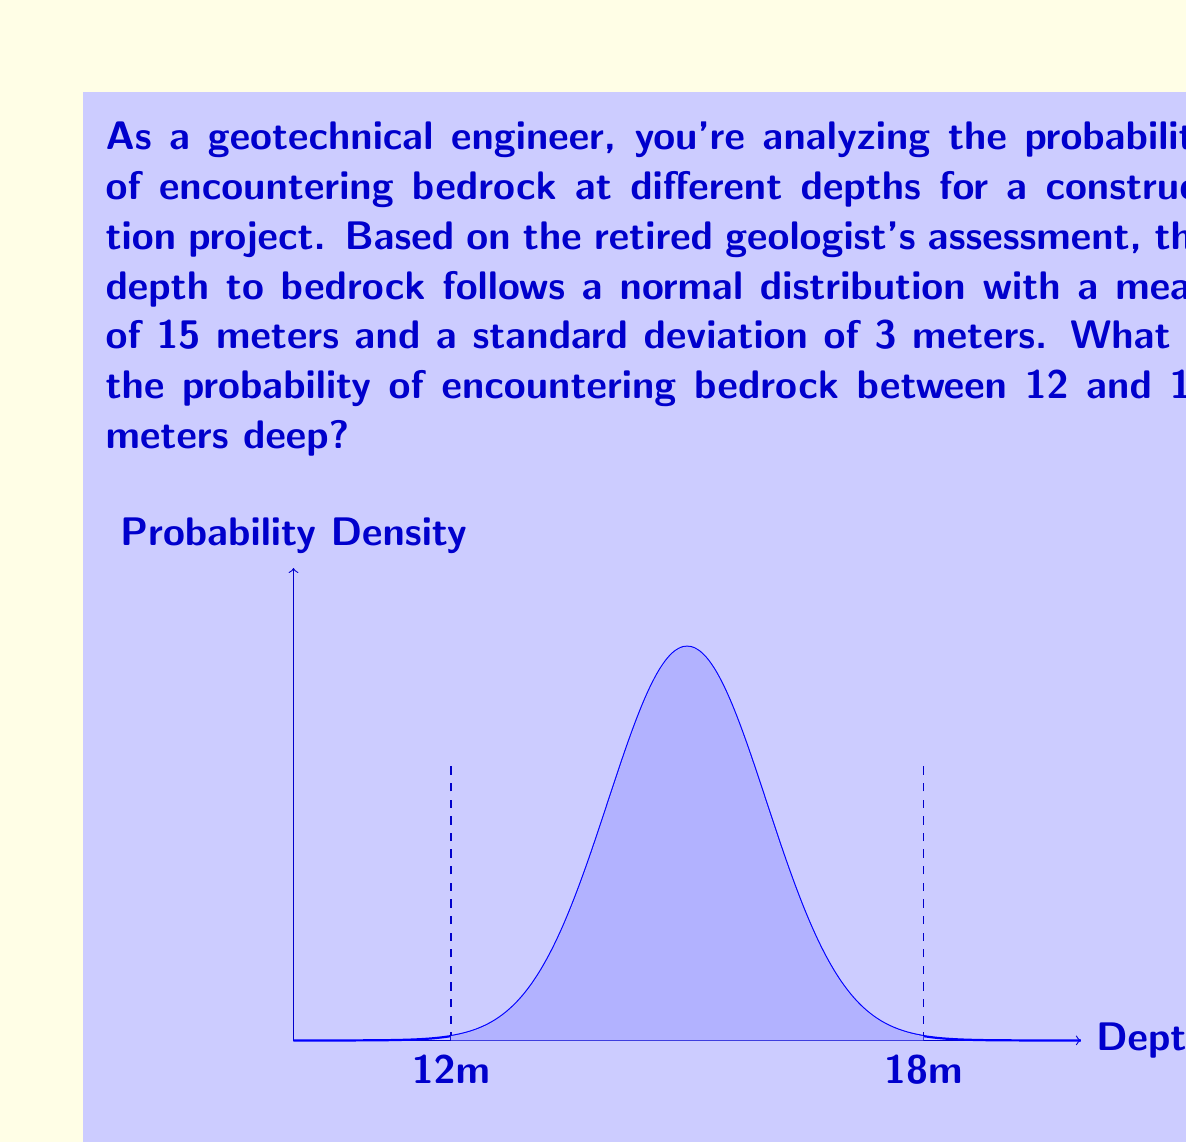Provide a solution to this math problem. To solve this problem, we need to use the properties of the normal distribution and the z-score formula. Let's approach this step-by-step:

1) We are given that the depth to bedrock follows a normal distribution with:
   Mean (μ) = 15 meters
   Standard deviation (σ) = 3 meters

2) We want to find the probability of encountering bedrock between 12 and 18 meters deep.

3) To use the standard normal distribution table, we need to convert these depths to z-scores:

   For 12 meters: $z_1 = \frac{x - \mu}{\sigma} = \frac{12 - 15}{3} = -1$

   For 18 meters: $z_2 = \frac{x - \mu}{\sigma} = \frac{18 - 15}{3} = 1$

4) Now, we need to find the area under the standard normal curve between z = -1 and z = 1.

5) This can be expressed as: $P(-1 < Z < 1)$

6) Using the symmetry of the normal distribution, this is equivalent to:
   $P(-1 < Z < 1) = 2 * P(0 < Z < 1)$

7) From the standard normal distribution table, we find that $P(0 < Z < 1) \approx 0.3413$

8) Therefore, $P(-1 < Z < 1) = 2 * 0.3413 = 0.6826$

Thus, the probability of encountering bedrock between 12 and 18 meters deep is approximately 0.6826 or 68.26%.
Answer: 0.6826 or 68.26% 